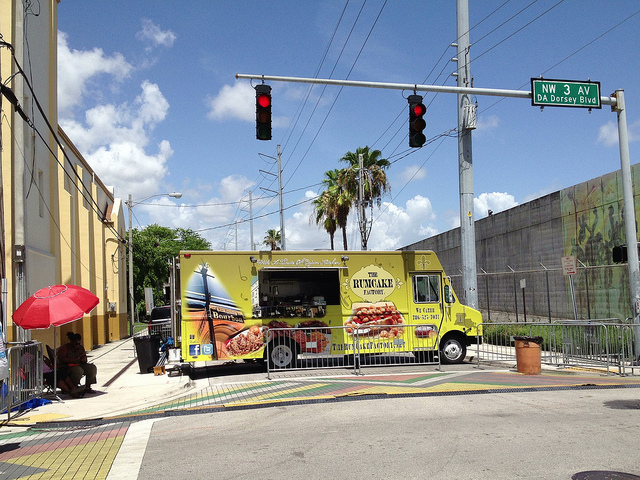Please identify all text content in this image. THE RUMGAKE f DA Dorsey AV 3 NW 